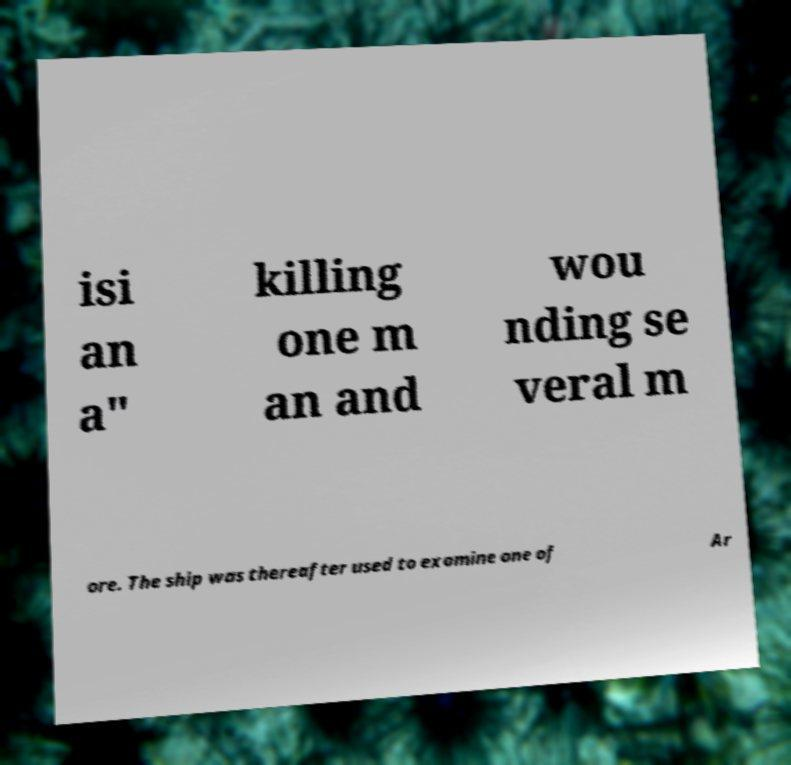Could you extract and type out the text from this image? isi an a" killing one m an and wou nding se veral m ore. The ship was thereafter used to examine one of Ar 